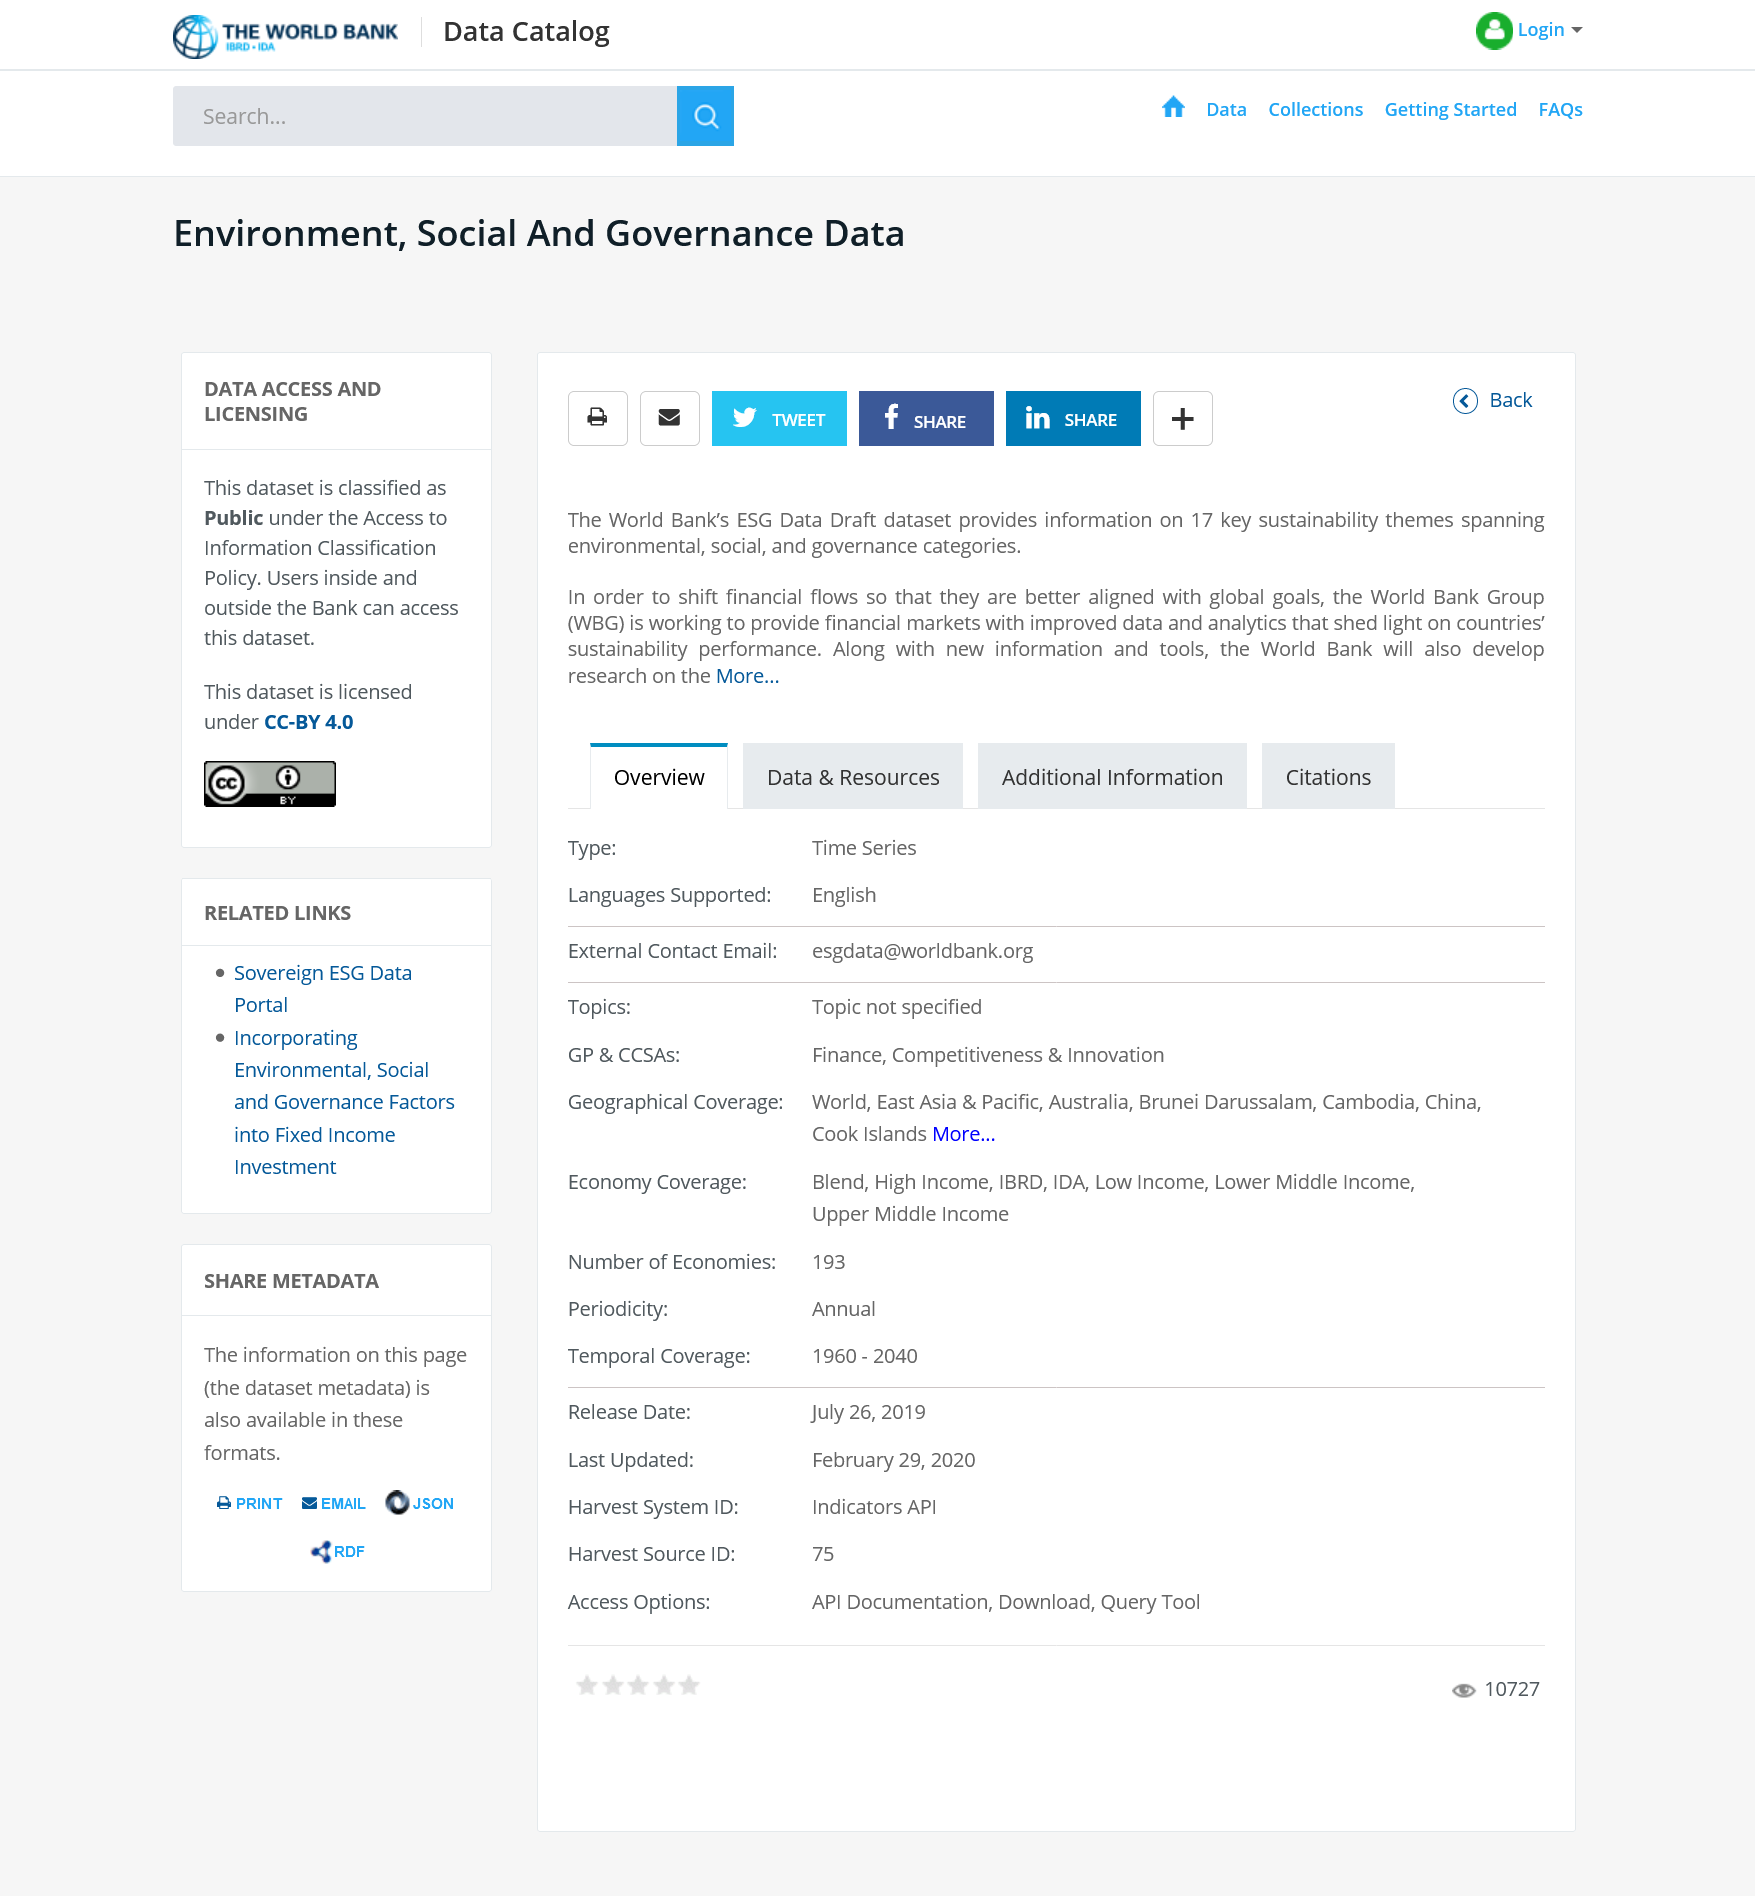Outline some significant characteristics in this image. The dataset is licensed under the Creative Commons Attribution 4.0 license. The World Bank's ESG Data Draft covers a total of 17 key sustainability themes. The sustainability themes span multiple categories including environmental, social, and governance categories. 